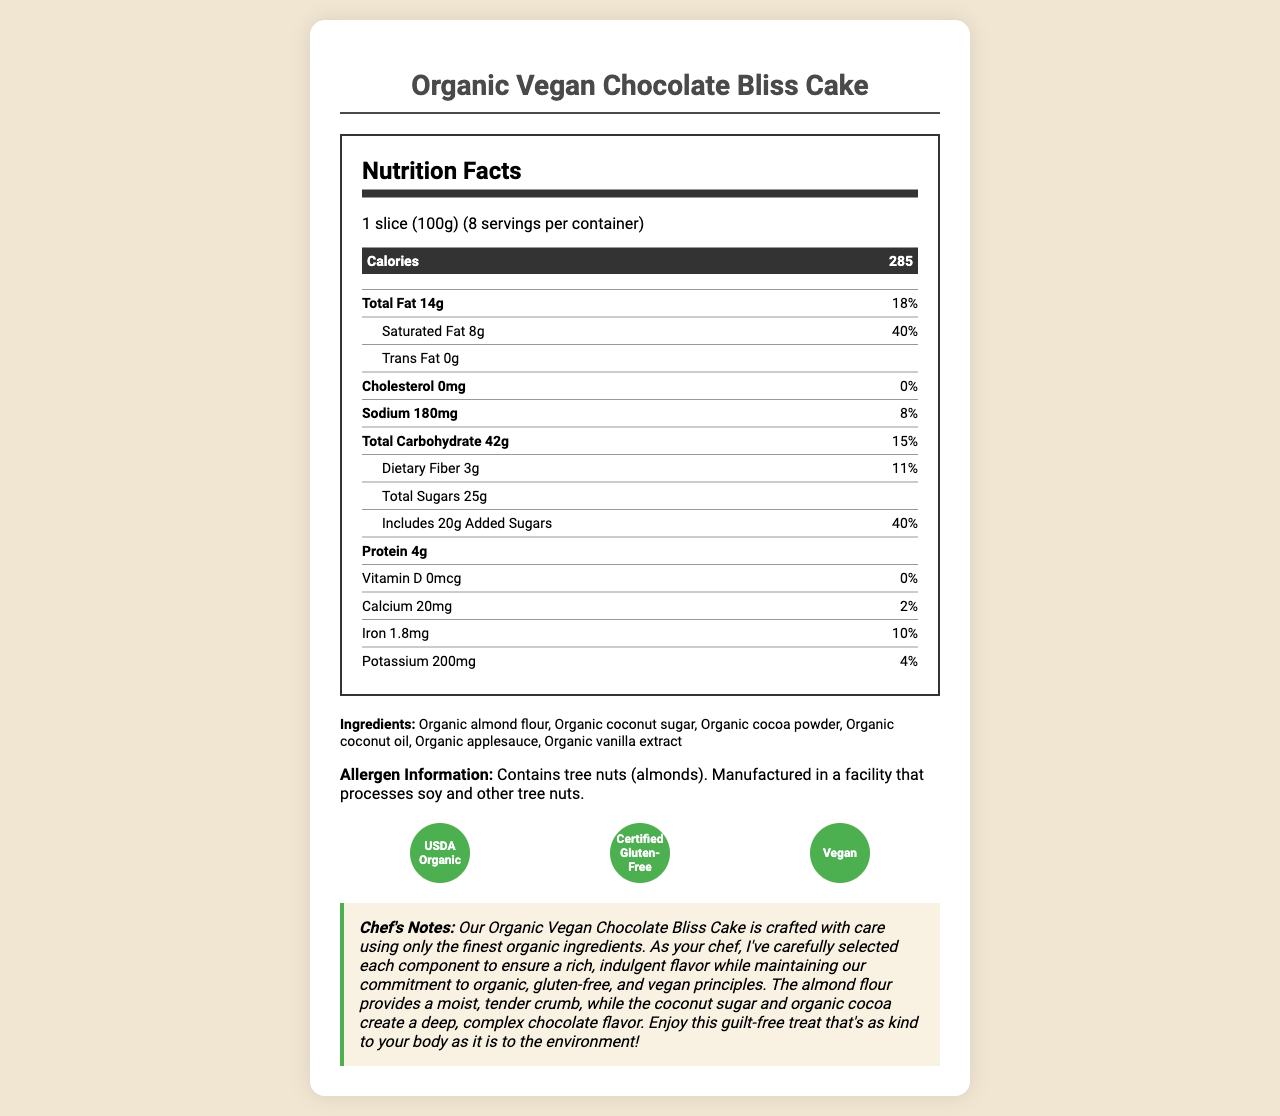What is the serving size of the Organic Vegan Chocolate Bliss Cake? The serving size is clearly indicated as "1 slice (100g)" in the document.
Answer: 1 slice (100g) How many servings are there per container? The document specifies that there are 8 servings per container.
Answer: 8 servings How many calories are in one serving? The calories per serving are listed as 285.
Answer: 285 calories How much total fat is in one serving, and what is its daily value percentage? The total fat content per serving is 14 grams, which equals 18% of the daily value.
Answer: 14g, 18% What is the amount of dietary fiber in one serving? The dietary fiber amount is listed as 3 grams.
Answer: 3 grams Does the cake contain any cholesterol? The document shows that the cholesterol amount is 0 mg, indicating that the cake contains no cholesterol.
Answer: No How much sodium is in one serving? The sodium content per serving is 180 mg.
Answer: 180 mg What is the total carbohydrate content in one serving? The total carbohydrate content per serving is 42 grams.
Answer: 42 grams How many grams of protein does one serving have? The protein content per serving is listed as 4 grams.
Answer: 4 grams What is the main source of sweetness in the cake? A. Organic white sugar B. Organic brown sugar C. Organic coconut sugar D. Honey The main ingredients list includes "Organic coconut sugar" as the source of sweetness.
Answer: C. Organic coconut sugar Which certification(s) does the Organic Vegan Chocolate Bliss Cake have? A. USDA Organic only B. Certified Gluten-Free only C. Vegan only D. All of the above The cake is certified USDA Organic, Certified Gluten-Free, and Vegan, as indicated in the certifications section.
Answer: D. All of the above Does the cake contain any tree nuts? The allergen information clearly states that the cake contains tree nuts (almonds).
Answer: Yes Summarize the key details of the Organic Vegan Chocolate Bliss Cake. The document provides detailed information about the cake's nutritional content, ingredients, allergens, and certifications. It emphasizes that the cake is a healthy, indulgent treat made with organic and vegan ingredients.
Answer: The Organic Vegan Chocolate Bliss Cake is a gluten-free, vegan dessert made with organic ingredients. Each slice (100g) contains 285 calories, 14g of fat (including 8g of saturated fat), 0g of cholesterol, 180mg of sodium, 42g of carbohydrates, 3g of dietary fiber, 25g of total sugars (including 20g of added sugars), and 4g of protein. The cake is made from organic almond flour, coconut sugar, cocoa powder, coconut oil, applesauce, and vanilla extract. It is certified USDA Organic, Certified Gluten-Free, and Vegan, with a special note from the chef emphasizing the high-quality organic ingredients used. How much vitamin D is in the cake? The document shows that the amount of vitamin D in the cake is 0 mcg.
Answer: 0 mcg What is the daily value percentage of iron in one serving? The daily value percentage of iron in one serving is 10%.
Answer: 10% In what facility is the cake manufactured? The document does not specify the exact facility where the cake is manufactured.
Answer: Not enough information Is the cake a good source of dietary fiber? With 11% of the daily value of dietary fiber per serving, it can be considered a good source of dietary fiber.
Answer: Yes 